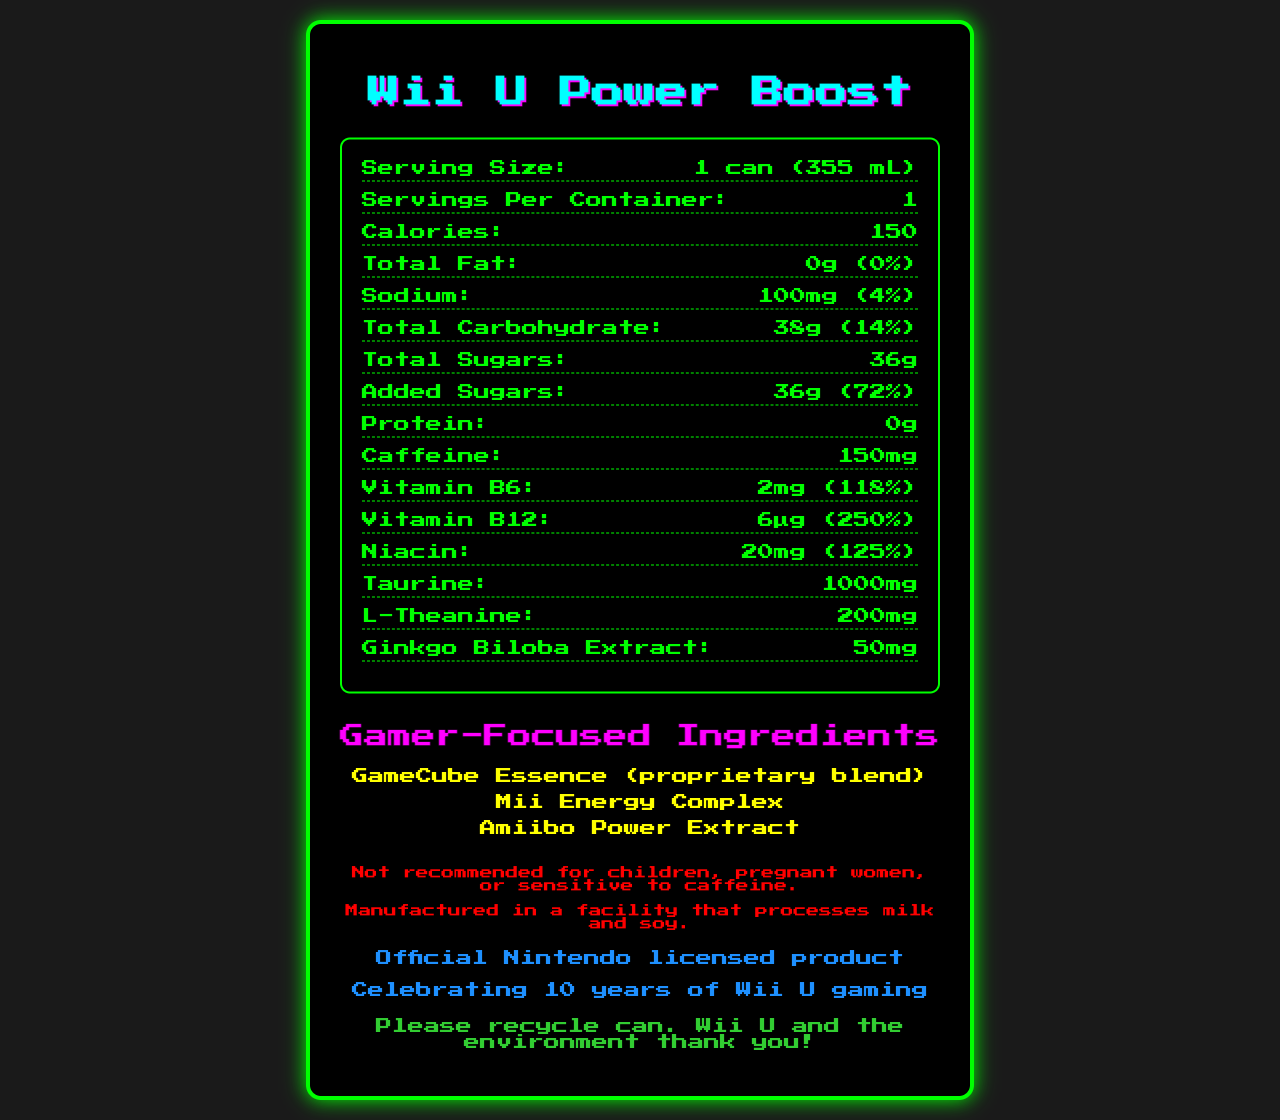what is the serving size of the Wii U Power Boost? The serving size is listed at the top of the nutrition facts section as "1 can (355 mL)".
Answer: 1 can (355 mL) how many calories are in a single serving of Wii U Power Boost? The calories per serving are mentioned in the nutrition facts section as "Calories: 150".
Answer: 150 how many grams of total sugars are in Wii U Power Boost? The total sugars are specified under the total carbohydrate section as "Total Sugars: 36g".
Answer: 36g how much caffeine is in one can of Wii U Power Boost? The amount of caffeine is listed as "Caffeine: 150mg" in the nutrition facts section.
Answer: 150mg what is the amount of sodium per serving, and what percentage of the daily value does it represent? Sodium content is mentioned as "100mg" which is "4%" of the daily value in the nutrition facts section.
Answer: 100mg, 4% which of the following vitamins are included in Wii U Power Boost? A. Vitamin C B. Vitamin B6 C. Vitamin B12 D. Vitamin A Both Vitamin B6 and Vitamin B12 are listed in the nutrition facts section, but not Vitamin C or Vitamin A.
Answer: B, C which gamer-focused ingredient is NOT listed in Wii U Power Boost? i. GameCube Essence ii. Joy-Con Juice iii. Mii Energy Complex iv. Amiibo Power Extract Joy-Con Juice is not listed; the listed ingredients are GameCube Essence, Mii Energy Complex, and Amiibo Power Extract.
Answer: ii does Wii U Power Boost contain protein? The nutrition facts label states "Protein: 0g".
Answer: No can the information about the recommended age for consuming Wii U Power Boost be found on the label? The disclaimer section says "Not recommended for children, pregnant women, or sensitive to caffeine."
Answer: Yes summarize the main idea of the Wii U Power Boost nutrition facts label. The document outlines various nutritional details of the Wii U Power Boost energy drink, highlighting its caloric content, high sugar and caffeine amounts, and gamer-focused ingredients. It also includes disclaimers for sensitive groups and mentions its status as an official Nintendo licensed product.
Answer: The Wii U Power Boost is an energy drink with gamer-focused ingredients, containing high amounts of sugars and caffeine, with added vitamins such as B6 and B12. It is a limited edition product celebrating 10 years of Wii U gaming, and it includes a disclaimer about caffeine sensitivity and allergen information. what is the daily value percentage of Vitamin B12 in Wii U Power Boost? The nutrition facts label states "Vitamin B12: 6µg (250%)".
Answer: 250% what are the gamer-focused ingredients specifically mentioned on this label? The gamer-focused ingredients are listed under a specific section titled "Gamer-Focused Ingredients".
Answer: GameCube Essence, Mii Energy Complex, Amiibo Power Extract how much taurine is present in one can of Wii U Power Boost? The nutrition facts label lists "Taurine: 1000mg".
Answer: 1000mg in which type of facility is Wii U Power Boost manufactured, according to the allergen information? The allergen information section states "Manufactured in a facility that processes milk and soy".
Answer: A facility that processes milk and soy how much niacin is in a single can of Wii U Power Boost, and what is its daily value percentage? The nutrition facts section lists "Niacin: 20mg (125%)".
Answer: 20mg, 125% what is the total amount of added sugars in Wii U Power Boost and their daily value percentage? The label specifies 36g of added sugars, which is 72% of the daily value.
Answer: 36g, 72% how many servings are included in one container of Wii U Power Boost? The serving information specifies "Servings Per Container: 1".
Answer: 1 does Wii U Power Boost label mention any partnership or licensing information? The label mentions "Official Nintendo licensed product".
Answer: Yes 